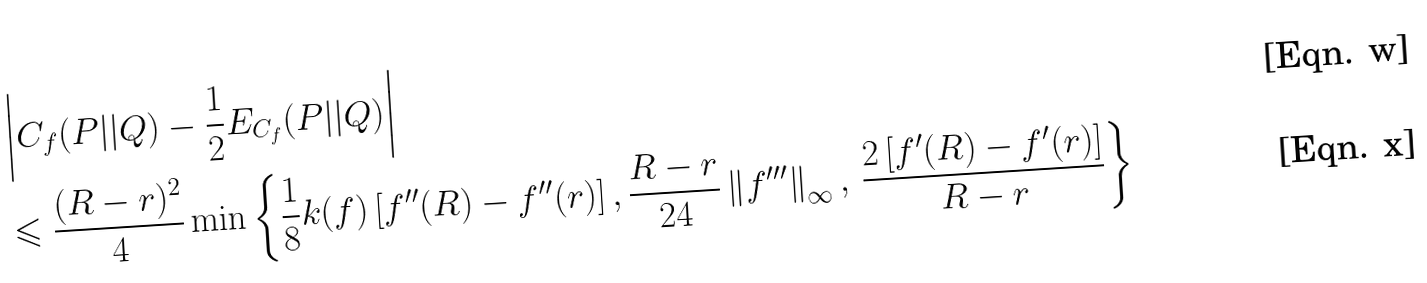Convert formula to latex. <formula><loc_0><loc_0><loc_500><loc_500>& \left | { C _ { f } ( P | | Q ) - \frac { 1 } { 2 } E _ { C _ { f } } ( P | | Q ) } \right | \\ & \leqslant \frac { ( R - r ) ^ { 2 } } { 4 } \min \left \{ { \frac { 1 } { 8 } k ( f ) \left [ { { f } ^ { \prime \prime } ( R ) - { f } ^ { \prime \prime } ( r ) } \right ] , } \, { \frac { R - r } { 2 4 } \left \| { f } ^ { \prime \prime \prime } \right \| _ { \infty } , \, \frac { 2 \left [ { { f } ^ { \prime } ( R ) - { f } ^ { \prime } ( r ) } \right ] } { R - r } } \right \}</formula> 